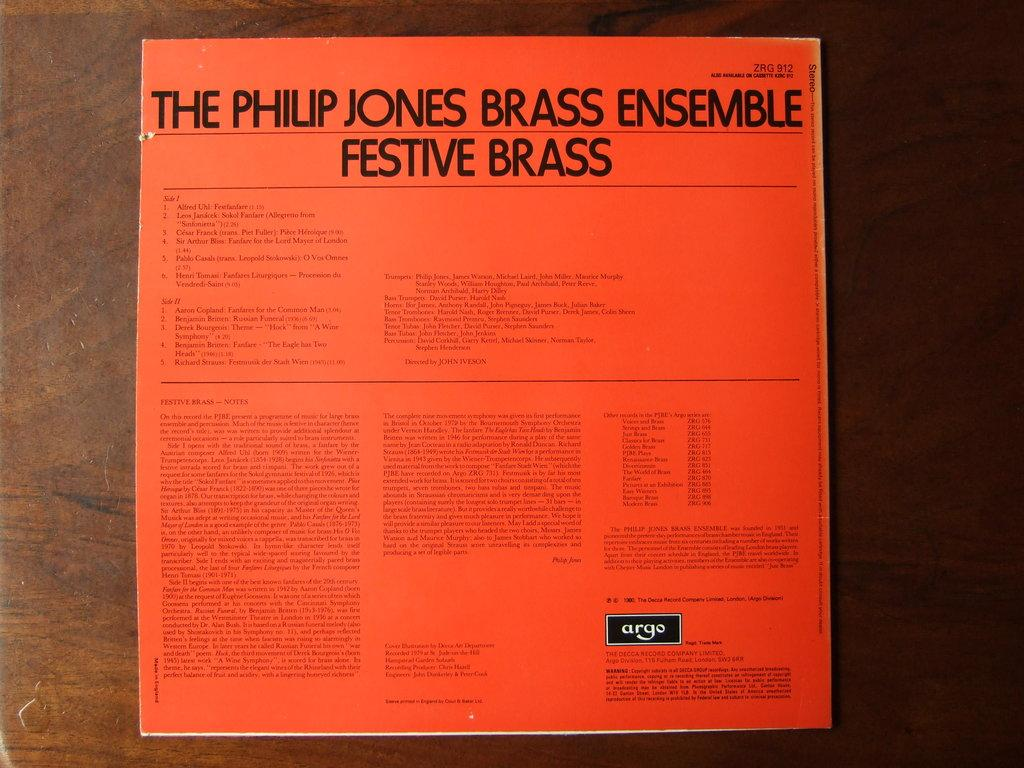What type of surface is visible in the image? There is a wooden surface in the image. What is placed on the wooden surface? There is a paper with information on the wooden surface. Can you see any sail or ocean in the image? No, there is no sail or ocean present in the image. What nation is depicted on the paper in the image? The provided facts do not mention any specific nation or information on the paper, so we cannot determine that from the image. 